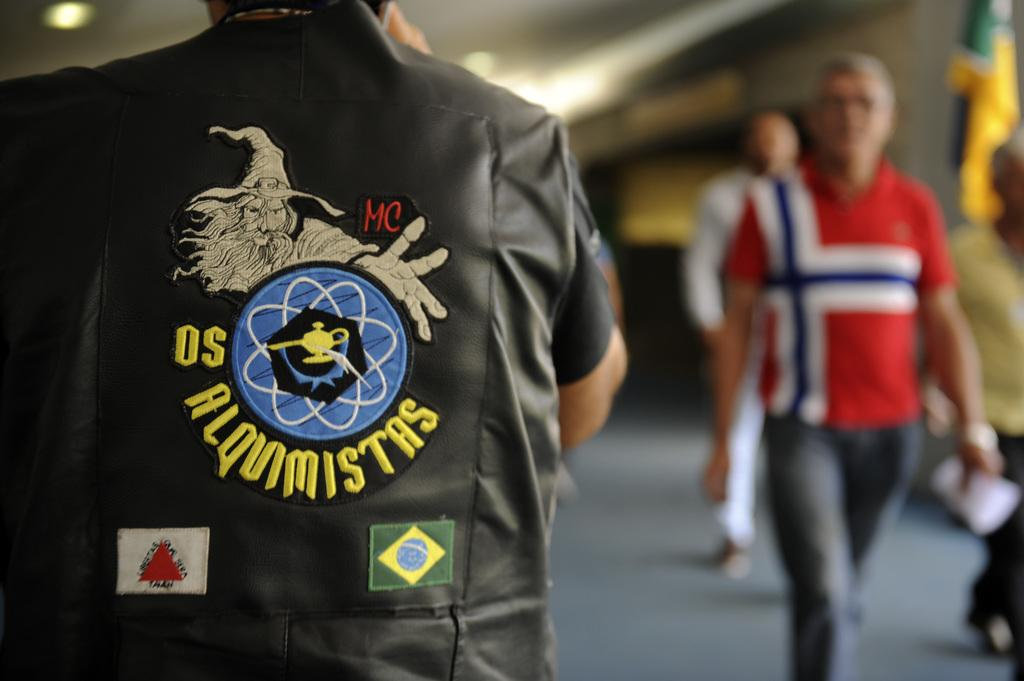<image>
Render a clear and concise summary of the photo. A person from brazil wears a jacket that identifies him as a member of the alquimistas motorcycle club. 